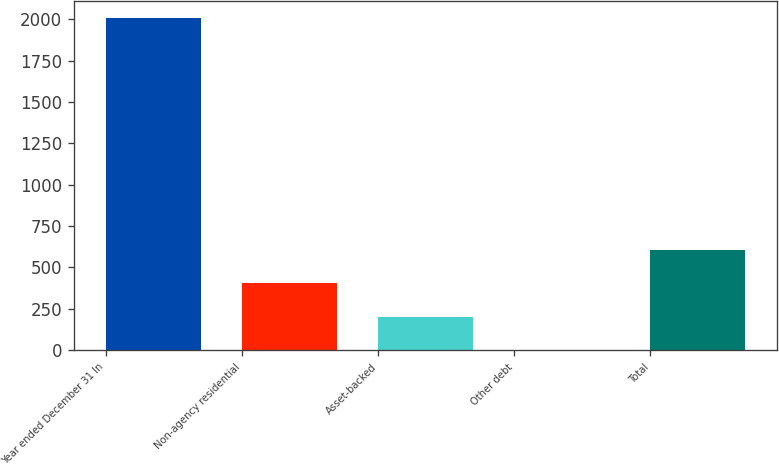Convert chart. <chart><loc_0><loc_0><loc_500><loc_500><bar_chart><fcel>Year ended December 31 In<fcel>Non-agency residential<fcel>Asset-backed<fcel>Other debt<fcel>Total<nl><fcel>2011<fcel>403<fcel>202<fcel>1<fcel>604<nl></chart> 